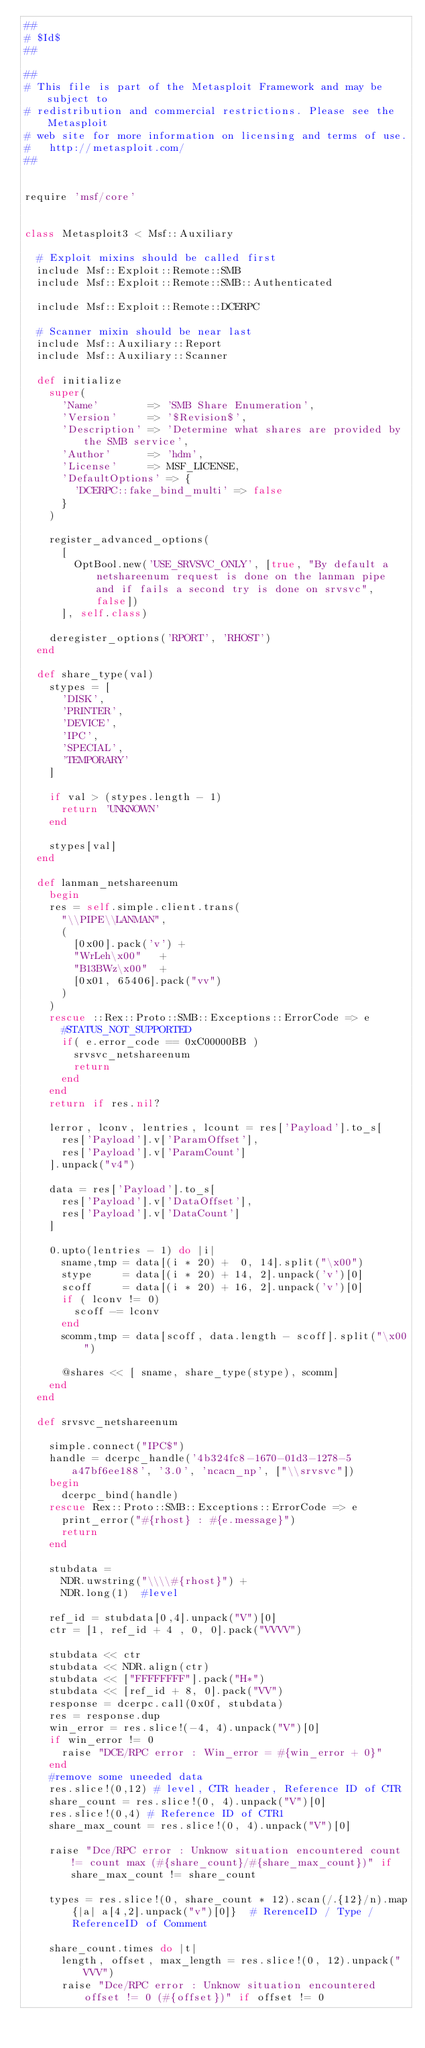<code> <loc_0><loc_0><loc_500><loc_500><_Ruby_>##
# $Id$
##

##
# This file is part of the Metasploit Framework and may be subject to
# redistribution and commercial restrictions. Please see the Metasploit
# web site for more information on licensing and terms of use.
#   http://metasploit.com/
##


require 'msf/core'


class Metasploit3 < Msf::Auxiliary

	# Exploit mixins should be called first
	include Msf::Exploit::Remote::SMB
	include Msf::Exploit::Remote::SMB::Authenticated

	include Msf::Exploit::Remote::DCERPC

	# Scanner mixin should be near last
	include Msf::Auxiliary::Report
	include Msf::Auxiliary::Scanner

	def initialize
		super(
			'Name'        => 'SMB Share Enumeration',
			'Version'     => '$Revision$',
			'Description' => 'Determine what shares are provided by the SMB service',
			'Author'      => 'hdm',
			'License'     => MSF_LICENSE,
			'DefaultOptions' => {
				'DCERPC::fake_bind_multi' => false
			}
		)

		register_advanced_options(
			[
				OptBool.new('USE_SRVSVC_ONLY', [true, "By default a netshareenum request is done on the lanman pipe and if fails a second try is done on srvsvc", false])
			], self.class)

		deregister_options('RPORT', 'RHOST')
	end

	def share_type(val)
		stypes = [
			'DISK',
			'PRINTER',
			'DEVICE',
			'IPC',
			'SPECIAL',
			'TEMPORARY'
		]

		if val > (stypes.length - 1)
			return 'UNKNOWN'
		end

		stypes[val]
	end

	def lanman_netshareenum
		begin
		res = self.simple.client.trans(
			"\\PIPE\\LANMAN",
			(
				[0x00].pack('v') +
				"WrLeh\x00"   +
				"B13BWz\x00"  +
				[0x01, 65406].pack("vv")
			)
		)
		rescue ::Rex::Proto::SMB::Exceptions::ErrorCode => e
			#STATUS_NOT_SUPPORTED
			if( e.error_code == 0xC00000BB )
				srvsvc_netshareenum
				return
			end
		end
		return if res.nil?

		lerror, lconv, lentries, lcount = res['Payload'].to_s[
			res['Payload'].v['ParamOffset'],
			res['Payload'].v['ParamCount']
		].unpack("v4")

		data = res['Payload'].to_s[
			res['Payload'].v['DataOffset'],
			res['Payload'].v['DataCount']
		]

		0.upto(lentries - 1) do |i|
			sname,tmp = data[(i * 20) +  0, 14].split("\x00")
			stype     = data[(i * 20) + 14, 2].unpack('v')[0]
			scoff     = data[(i * 20) + 16, 2].unpack('v')[0]
			if ( lconv != 0)
				scoff -= lconv
			end
			scomm,tmp = data[scoff, data.length - scoff].split("\x00")

			@shares << [ sname, share_type(stype), scomm]
		end
	end

	def srvsvc_netshareenum

		simple.connect("IPC$")
		handle = dcerpc_handle('4b324fc8-1670-01d3-1278-5a47bf6ee188', '3.0', 'ncacn_np', ["\\srvsvc"])
		begin
			dcerpc_bind(handle)
		rescue Rex::Proto::SMB::Exceptions::ErrorCode => e
			print_error("#{rhost} : #{e.message}")
			return
		end

		stubdata =
			NDR.uwstring("\\\\#{rhost}") +
			NDR.long(1)  #level

		ref_id = stubdata[0,4].unpack("V")[0]
		ctr = [1, ref_id + 4 , 0, 0].pack("VVVV")

		stubdata << ctr
		stubdata << NDR.align(ctr)
		stubdata << ["FFFFFFFF"].pack("H*")
		stubdata << [ref_id + 8, 0].pack("VV")
		response = dcerpc.call(0x0f, stubdata)
		res = response.dup
		win_error = res.slice!(-4, 4).unpack("V")[0]
		if win_error != 0
			raise "DCE/RPC error : Win_error = #{win_error + 0}"
		end
		#remove some uneeded data
		res.slice!(0,12) # level, CTR header, Reference ID of CTR
		share_count = res.slice!(0, 4).unpack("V")[0]
		res.slice!(0,4) # Reference ID of CTR1
		share_max_count = res.slice!(0, 4).unpack("V")[0]

		raise "Dce/RPC error : Unknow situation encountered count != count max (#{share_count}/#{share_max_count})" if share_max_count != share_count

		types = res.slice!(0, share_count * 12).scan(/.{12}/n).map{|a| a[4,2].unpack("v")[0]}  # RerenceID / Type / ReferenceID of Comment

		share_count.times do |t|
			length, offset, max_length = res.slice!(0, 12).unpack("VVV")
			raise "Dce/RPC error : Unknow situation encountered offset != 0 (#{offset})" if offset != 0</code> 